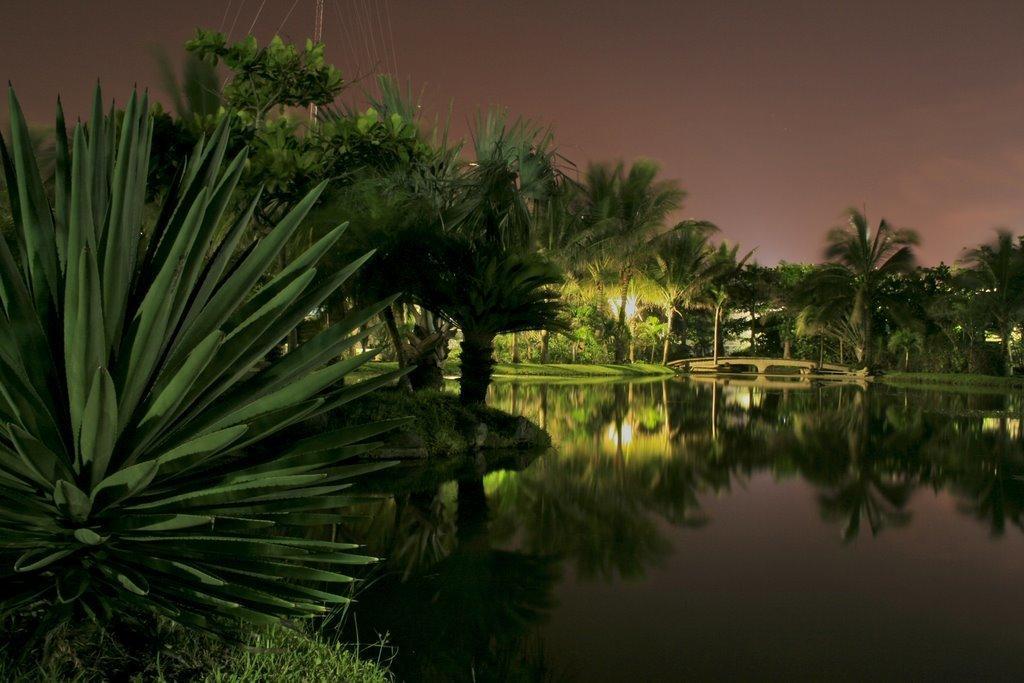Please provide a concise description of this image. In this image we can see many trees and plants. There is a lake in the image. There is a reflection of trees on the water. There is a grassy land in the image. There is a sky in the image. There is a pole and few cables in the image. 